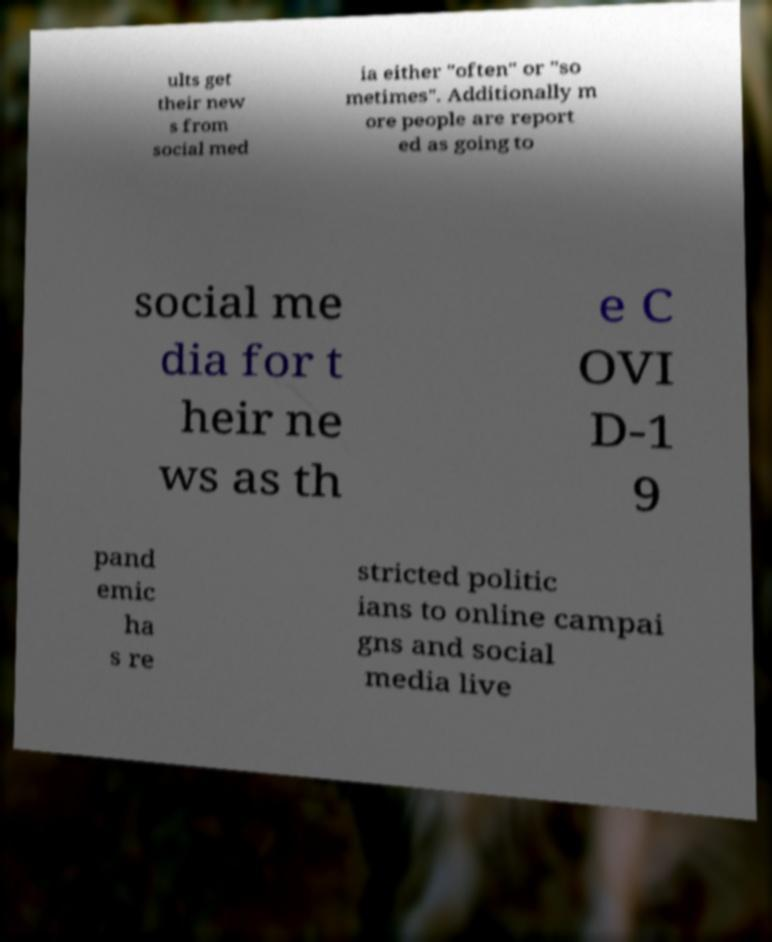Can you accurately transcribe the text from the provided image for me? ults get their new s from social med ia either "often" or "so metimes". Additionally m ore people are report ed as going to social me dia for t heir ne ws as th e C OVI D-1 9 pand emic ha s re stricted politic ians to online campai gns and social media live 